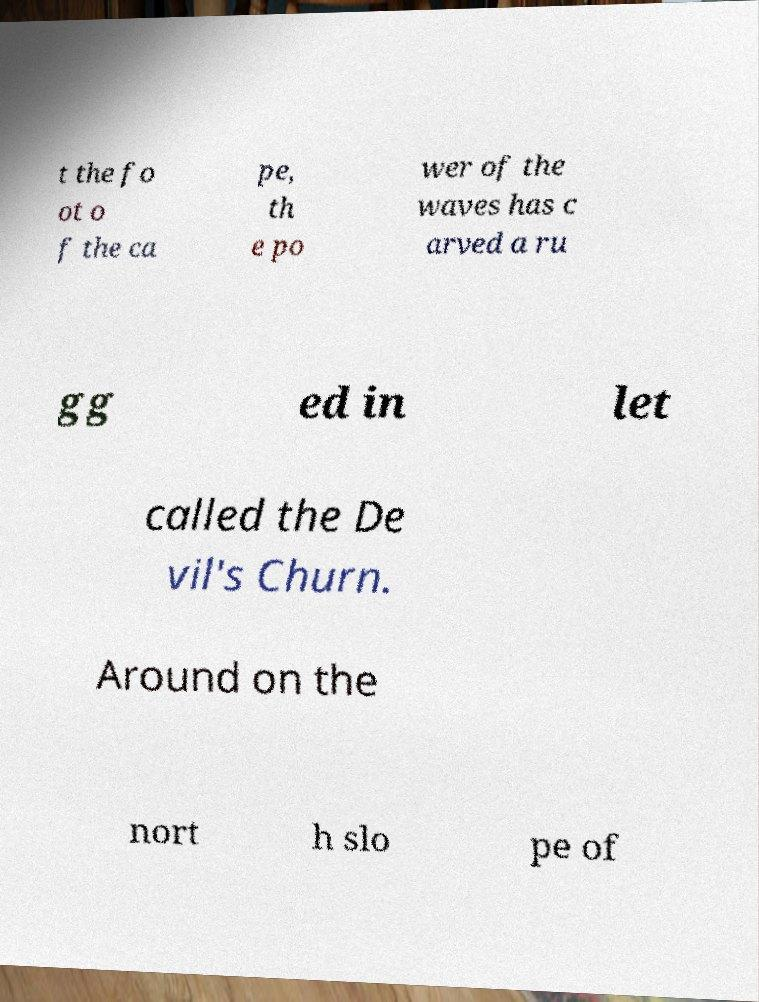There's text embedded in this image that I need extracted. Can you transcribe it verbatim? t the fo ot o f the ca pe, th e po wer of the waves has c arved a ru gg ed in let called the De vil's Churn. Around on the nort h slo pe of 